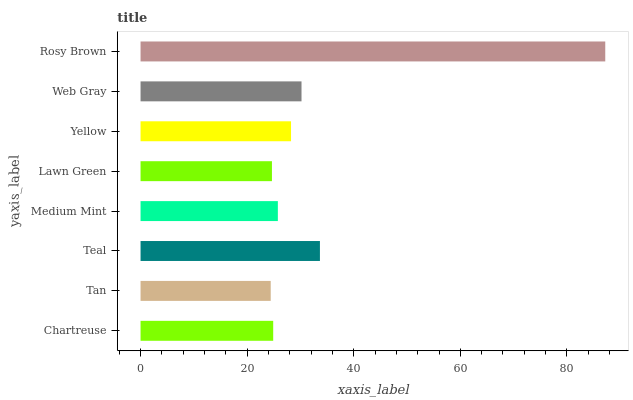Is Tan the minimum?
Answer yes or no. Yes. Is Rosy Brown the maximum?
Answer yes or no. Yes. Is Teal the minimum?
Answer yes or no. No. Is Teal the maximum?
Answer yes or no. No. Is Teal greater than Tan?
Answer yes or no. Yes. Is Tan less than Teal?
Answer yes or no. Yes. Is Tan greater than Teal?
Answer yes or no. No. Is Teal less than Tan?
Answer yes or no. No. Is Yellow the high median?
Answer yes or no. Yes. Is Medium Mint the low median?
Answer yes or no. Yes. Is Medium Mint the high median?
Answer yes or no. No. Is Web Gray the low median?
Answer yes or no. No. 